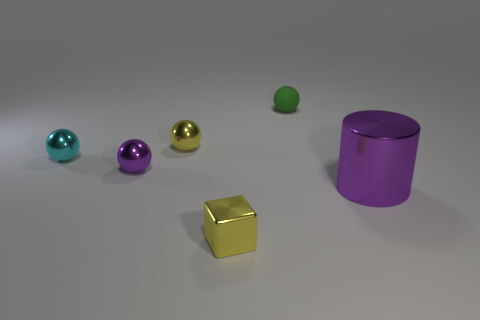Subtract all tiny cyan metallic spheres. How many spheres are left? 3 Subtract all cubes. How many objects are left? 5 Subtract 4 spheres. How many spheres are left? 0 Subtract all green blocks. Subtract all cyan balls. How many blocks are left? 1 Subtract all blue balls. How many brown cubes are left? 0 Subtract all gray spheres. Subtract all purple cylinders. How many objects are left? 5 Add 3 small cubes. How many small cubes are left? 4 Add 1 balls. How many balls exist? 5 Add 3 green rubber balls. How many objects exist? 9 Subtract all green balls. How many balls are left? 3 